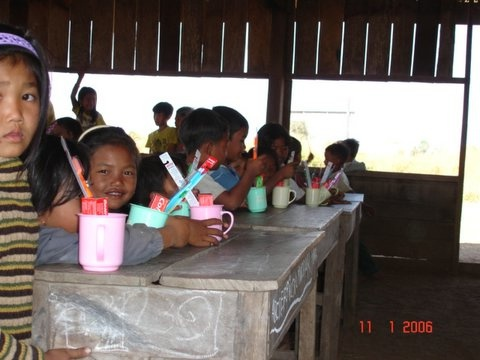Describe the objects in this image and their specific colors. I can see people in black, gray, and tan tones, people in black, gray, and brown tones, people in black, brown, and maroon tones, people in black, maroon, darkgray, and brown tones, and cup in black, lavender, pink, and lightpink tones in this image. 